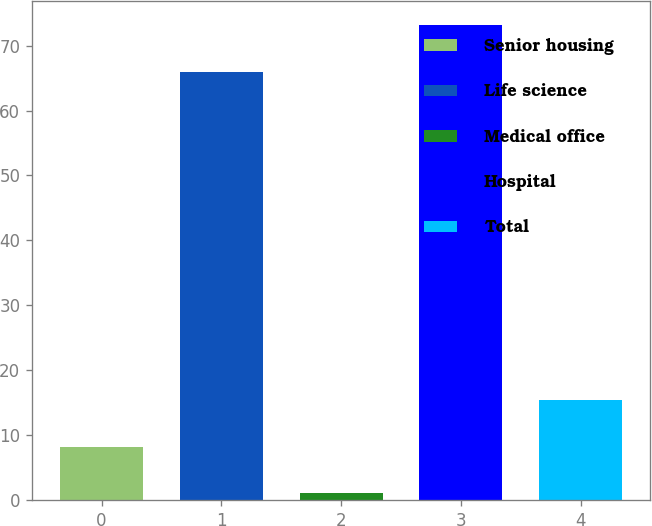Convert chart to OTSL. <chart><loc_0><loc_0><loc_500><loc_500><bar_chart><fcel>Senior housing<fcel>Life science<fcel>Medical office<fcel>Hospital<fcel>Total<nl><fcel>8.2<fcel>66<fcel>1<fcel>73.2<fcel>15.4<nl></chart> 